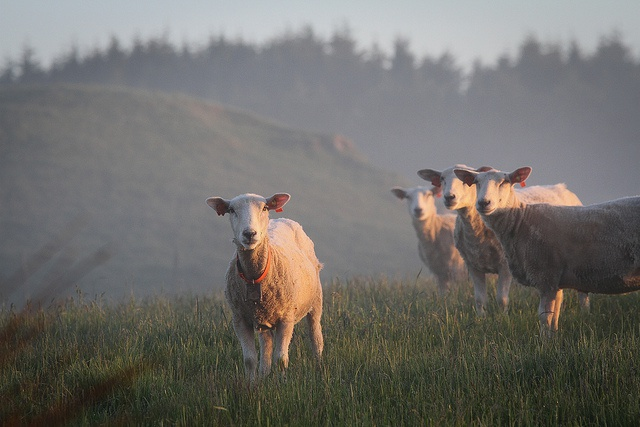Describe the objects in this image and their specific colors. I can see sheep in darkgray, black, and gray tones, sheep in darkgray, gray, tan, and black tones, sheep in darkgray, gray, tan, and black tones, and sheep in darkgray, gray, and tan tones in this image. 